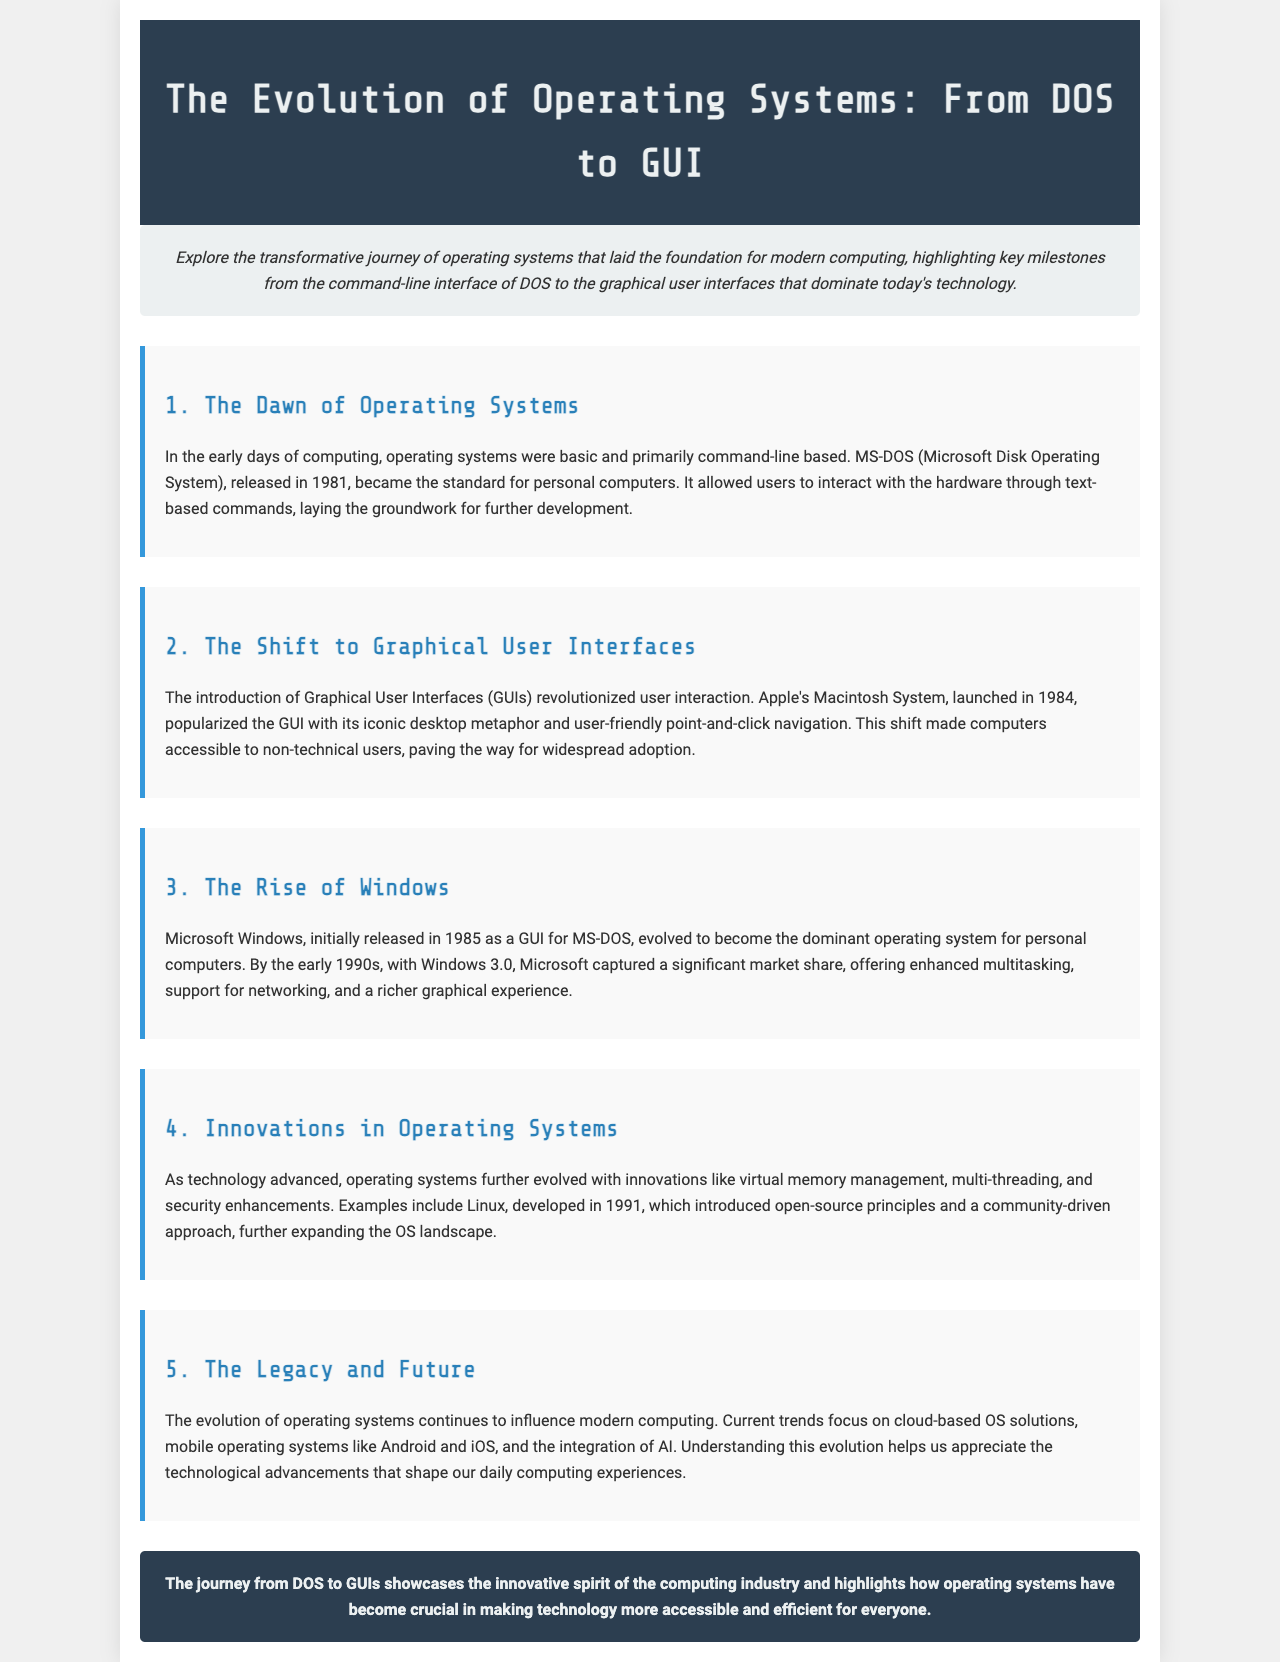What year was MS-DOS released? The document states that MS-DOS was released in 1981.
Answer: 1981 Which operating system popularized the GUI? The document mentions Apple's Macintosh System, launched in 1984, popularized the GUI.
Answer: Macintosh System When was Linux developed? The document indicates that Linux was developed in 1991.
Answer: 1991 What concept did Linux introduce? The document describes Linux as introducing open-source principles.
Answer: Open-source What type of solutions are current OS trends focusing on? The document mentions current trends focus on cloud-based OS solutions.
Answer: Cloud-based Which version of Windows significantly increased market share? The document indicates that Windows 3.0 captured a significant market share.
Answer: Windows 3.0 What foundational technology did MS-DOS provide? The document states that MS-DOS allowed interaction with hardware through text-based commands.
Answer: Text-based commands What metaphor was popularized by Apple's GUI? The document refers to the iconic desktop metaphor introduced by Apple's Macintosh System.
Answer: Desktop metaphor What major shift did GUIs create for user accessibility? The document mentions that GUIs made computers accessible to non-technical users.
Answer: Accessibility 